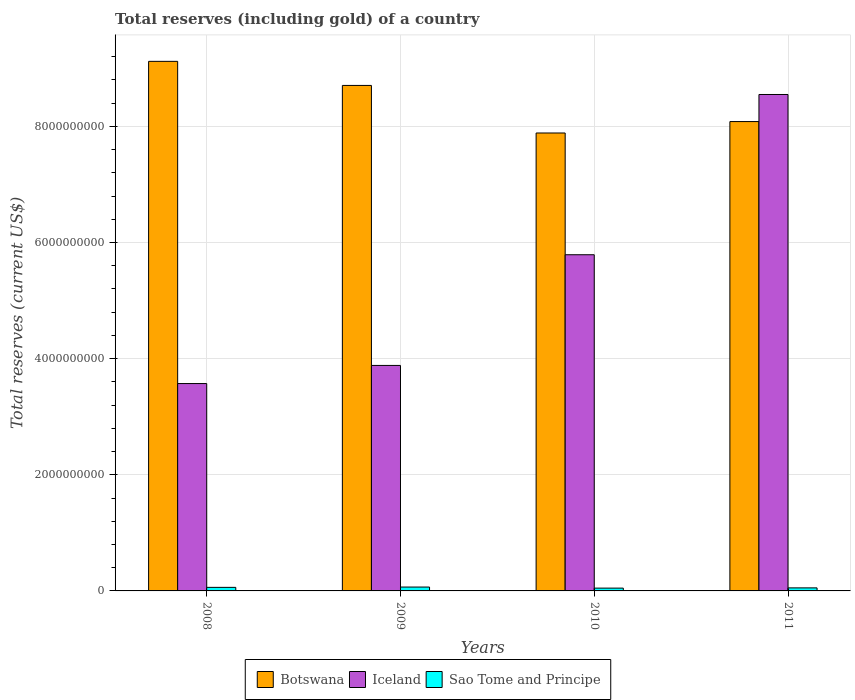How many groups of bars are there?
Offer a very short reply. 4. Are the number of bars on each tick of the X-axis equal?
Your answer should be compact. Yes. What is the total reserves (including gold) in Iceland in 2010?
Provide a succinct answer. 5.79e+09. Across all years, what is the maximum total reserves (including gold) in Sao Tome and Principe?
Keep it short and to the point. 6.67e+07. Across all years, what is the minimum total reserves (including gold) in Iceland?
Your response must be concise. 3.57e+09. What is the total total reserves (including gold) in Botswana in the graph?
Your answer should be compact. 3.38e+1. What is the difference between the total reserves (including gold) in Botswana in 2008 and that in 2009?
Provide a succinct answer. 4.15e+08. What is the difference between the total reserves (including gold) in Sao Tome and Principe in 2008 and the total reserves (including gold) in Iceland in 2010?
Keep it short and to the point. -5.73e+09. What is the average total reserves (including gold) in Botswana per year?
Your answer should be compact. 8.45e+09. In the year 2011, what is the difference between the total reserves (including gold) in Iceland and total reserves (including gold) in Botswana?
Ensure brevity in your answer.  4.66e+08. What is the ratio of the total reserves (including gold) in Sao Tome and Principe in 2009 to that in 2010?
Your answer should be very brief. 1.38. What is the difference between the highest and the second highest total reserves (including gold) in Sao Tome and Principe?
Provide a short and direct response. 5.37e+06. What is the difference between the highest and the lowest total reserves (including gold) in Sao Tome and Principe?
Your answer should be very brief. 1.85e+07. In how many years, is the total reserves (including gold) in Sao Tome and Principe greater than the average total reserves (including gold) in Sao Tome and Principe taken over all years?
Your answer should be compact. 2. What does the 1st bar from the left in 2011 represents?
Make the answer very short. Botswana. What does the 1st bar from the right in 2009 represents?
Offer a very short reply. Sao Tome and Principe. Is it the case that in every year, the sum of the total reserves (including gold) in Sao Tome and Principe and total reserves (including gold) in Botswana is greater than the total reserves (including gold) in Iceland?
Offer a very short reply. No. How many bars are there?
Your answer should be very brief. 12. Are the values on the major ticks of Y-axis written in scientific E-notation?
Offer a very short reply. No. Where does the legend appear in the graph?
Keep it short and to the point. Bottom center. What is the title of the graph?
Make the answer very short. Total reserves (including gold) of a country. What is the label or title of the Y-axis?
Provide a short and direct response. Total reserves (current US$). What is the Total reserves (current US$) in Botswana in 2008?
Make the answer very short. 9.12e+09. What is the Total reserves (current US$) of Iceland in 2008?
Give a very brief answer. 3.57e+09. What is the Total reserves (current US$) of Sao Tome and Principe in 2008?
Keep it short and to the point. 6.13e+07. What is the Total reserves (current US$) of Botswana in 2009?
Your answer should be compact. 8.70e+09. What is the Total reserves (current US$) in Iceland in 2009?
Ensure brevity in your answer.  3.88e+09. What is the Total reserves (current US$) in Sao Tome and Principe in 2009?
Keep it short and to the point. 6.67e+07. What is the Total reserves (current US$) in Botswana in 2010?
Offer a very short reply. 7.89e+09. What is the Total reserves (current US$) of Iceland in 2010?
Your answer should be very brief. 5.79e+09. What is the Total reserves (current US$) of Sao Tome and Principe in 2010?
Offer a terse response. 4.82e+07. What is the Total reserves (current US$) of Botswana in 2011?
Provide a short and direct response. 8.08e+09. What is the Total reserves (current US$) in Iceland in 2011?
Your response must be concise. 8.55e+09. What is the Total reserves (current US$) of Sao Tome and Principe in 2011?
Your answer should be very brief. 5.23e+07. Across all years, what is the maximum Total reserves (current US$) of Botswana?
Offer a terse response. 9.12e+09. Across all years, what is the maximum Total reserves (current US$) in Iceland?
Provide a short and direct response. 8.55e+09. Across all years, what is the maximum Total reserves (current US$) in Sao Tome and Principe?
Provide a succinct answer. 6.67e+07. Across all years, what is the minimum Total reserves (current US$) in Botswana?
Provide a succinct answer. 7.89e+09. Across all years, what is the minimum Total reserves (current US$) of Iceland?
Offer a very short reply. 3.57e+09. Across all years, what is the minimum Total reserves (current US$) in Sao Tome and Principe?
Offer a very short reply. 4.82e+07. What is the total Total reserves (current US$) of Botswana in the graph?
Give a very brief answer. 3.38e+1. What is the total Total reserves (current US$) in Iceland in the graph?
Keep it short and to the point. 2.18e+1. What is the total Total reserves (current US$) of Sao Tome and Principe in the graph?
Offer a very short reply. 2.28e+08. What is the difference between the Total reserves (current US$) of Botswana in 2008 and that in 2009?
Your response must be concise. 4.15e+08. What is the difference between the Total reserves (current US$) of Iceland in 2008 and that in 2009?
Make the answer very short. -3.12e+08. What is the difference between the Total reserves (current US$) in Sao Tome and Principe in 2008 and that in 2009?
Keep it short and to the point. -5.37e+06. What is the difference between the Total reserves (current US$) of Botswana in 2008 and that in 2010?
Give a very brief answer. 1.23e+09. What is the difference between the Total reserves (current US$) in Iceland in 2008 and that in 2010?
Your response must be concise. -2.22e+09. What is the difference between the Total reserves (current US$) of Sao Tome and Principe in 2008 and that in 2010?
Provide a succinct answer. 1.31e+07. What is the difference between the Total reserves (current US$) of Botswana in 2008 and that in 2011?
Your answer should be very brief. 1.04e+09. What is the difference between the Total reserves (current US$) of Iceland in 2008 and that in 2011?
Provide a short and direct response. -4.98e+09. What is the difference between the Total reserves (current US$) in Sao Tome and Principe in 2008 and that in 2011?
Offer a terse response. 8.99e+06. What is the difference between the Total reserves (current US$) of Botswana in 2009 and that in 2010?
Make the answer very short. 8.19e+08. What is the difference between the Total reserves (current US$) in Iceland in 2009 and that in 2010?
Your answer should be very brief. -1.91e+09. What is the difference between the Total reserves (current US$) of Sao Tome and Principe in 2009 and that in 2010?
Your answer should be compact. 1.85e+07. What is the difference between the Total reserves (current US$) in Botswana in 2009 and that in 2011?
Give a very brief answer. 6.22e+08. What is the difference between the Total reserves (current US$) in Iceland in 2009 and that in 2011?
Keep it short and to the point. -4.67e+09. What is the difference between the Total reserves (current US$) in Sao Tome and Principe in 2009 and that in 2011?
Make the answer very short. 1.44e+07. What is the difference between the Total reserves (current US$) in Botswana in 2010 and that in 2011?
Provide a short and direct response. -1.97e+08. What is the difference between the Total reserves (current US$) in Iceland in 2010 and that in 2011?
Provide a succinct answer. -2.76e+09. What is the difference between the Total reserves (current US$) of Sao Tome and Principe in 2010 and that in 2011?
Make the answer very short. -4.13e+06. What is the difference between the Total reserves (current US$) in Botswana in 2008 and the Total reserves (current US$) in Iceland in 2009?
Your answer should be compact. 5.24e+09. What is the difference between the Total reserves (current US$) of Botswana in 2008 and the Total reserves (current US$) of Sao Tome and Principe in 2009?
Your response must be concise. 9.05e+09. What is the difference between the Total reserves (current US$) in Iceland in 2008 and the Total reserves (current US$) in Sao Tome and Principe in 2009?
Provide a succinct answer. 3.50e+09. What is the difference between the Total reserves (current US$) of Botswana in 2008 and the Total reserves (current US$) of Iceland in 2010?
Offer a terse response. 3.33e+09. What is the difference between the Total reserves (current US$) in Botswana in 2008 and the Total reserves (current US$) in Sao Tome and Principe in 2010?
Offer a very short reply. 9.07e+09. What is the difference between the Total reserves (current US$) in Iceland in 2008 and the Total reserves (current US$) in Sao Tome and Principe in 2010?
Your answer should be very brief. 3.52e+09. What is the difference between the Total reserves (current US$) in Botswana in 2008 and the Total reserves (current US$) in Iceland in 2011?
Offer a terse response. 5.71e+08. What is the difference between the Total reserves (current US$) of Botswana in 2008 and the Total reserves (current US$) of Sao Tome and Principe in 2011?
Offer a terse response. 9.07e+09. What is the difference between the Total reserves (current US$) in Iceland in 2008 and the Total reserves (current US$) in Sao Tome and Principe in 2011?
Your answer should be compact. 3.52e+09. What is the difference between the Total reserves (current US$) in Botswana in 2009 and the Total reserves (current US$) in Iceland in 2010?
Your response must be concise. 2.92e+09. What is the difference between the Total reserves (current US$) of Botswana in 2009 and the Total reserves (current US$) of Sao Tome and Principe in 2010?
Ensure brevity in your answer.  8.66e+09. What is the difference between the Total reserves (current US$) of Iceland in 2009 and the Total reserves (current US$) of Sao Tome and Principe in 2010?
Ensure brevity in your answer.  3.83e+09. What is the difference between the Total reserves (current US$) in Botswana in 2009 and the Total reserves (current US$) in Iceland in 2011?
Your answer should be very brief. 1.56e+08. What is the difference between the Total reserves (current US$) in Botswana in 2009 and the Total reserves (current US$) in Sao Tome and Principe in 2011?
Provide a short and direct response. 8.65e+09. What is the difference between the Total reserves (current US$) of Iceland in 2009 and the Total reserves (current US$) of Sao Tome and Principe in 2011?
Give a very brief answer. 3.83e+09. What is the difference between the Total reserves (current US$) of Botswana in 2010 and the Total reserves (current US$) of Iceland in 2011?
Your answer should be very brief. -6.63e+08. What is the difference between the Total reserves (current US$) of Botswana in 2010 and the Total reserves (current US$) of Sao Tome and Principe in 2011?
Your response must be concise. 7.83e+09. What is the difference between the Total reserves (current US$) of Iceland in 2010 and the Total reserves (current US$) of Sao Tome and Principe in 2011?
Give a very brief answer. 5.74e+09. What is the average Total reserves (current US$) in Botswana per year?
Give a very brief answer. 8.45e+09. What is the average Total reserves (current US$) of Iceland per year?
Ensure brevity in your answer.  5.45e+09. What is the average Total reserves (current US$) of Sao Tome and Principe per year?
Your answer should be very brief. 5.71e+07. In the year 2008, what is the difference between the Total reserves (current US$) in Botswana and Total reserves (current US$) in Iceland?
Give a very brief answer. 5.55e+09. In the year 2008, what is the difference between the Total reserves (current US$) in Botswana and Total reserves (current US$) in Sao Tome and Principe?
Provide a short and direct response. 9.06e+09. In the year 2008, what is the difference between the Total reserves (current US$) of Iceland and Total reserves (current US$) of Sao Tome and Principe?
Make the answer very short. 3.51e+09. In the year 2009, what is the difference between the Total reserves (current US$) in Botswana and Total reserves (current US$) in Iceland?
Keep it short and to the point. 4.82e+09. In the year 2009, what is the difference between the Total reserves (current US$) of Botswana and Total reserves (current US$) of Sao Tome and Principe?
Offer a terse response. 8.64e+09. In the year 2009, what is the difference between the Total reserves (current US$) in Iceland and Total reserves (current US$) in Sao Tome and Principe?
Make the answer very short. 3.82e+09. In the year 2010, what is the difference between the Total reserves (current US$) in Botswana and Total reserves (current US$) in Iceland?
Your answer should be very brief. 2.10e+09. In the year 2010, what is the difference between the Total reserves (current US$) of Botswana and Total reserves (current US$) of Sao Tome and Principe?
Give a very brief answer. 7.84e+09. In the year 2010, what is the difference between the Total reserves (current US$) in Iceland and Total reserves (current US$) in Sao Tome and Principe?
Your response must be concise. 5.74e+09. In the year 2011, what is the difference between the Total reserves (current US$) in Botswana and Total reserves (current US$) in Iceland?
Provide a succinct answer. -4.66e+08. In the year 2011, what is the difference between the Total reserves (current US$) in Botswana and Total reserves (current US$) in Sao Tome and Principe?
Your response must be concise. 8.03e+09. In the year 2011, what is the difference between the Total reserves (current US$) in Iceland and Total reserves (current US$) in Sao Tome and Principe?
Give a very brief answer. 8.50e+09. What is the ratio of the Total reserves (current US$) of Botswana in 2008 to that in 2009?
Offer a very short reply. 1.05. What is the ratio of the Total reserves (current US$) of Iceland in 2008 to that in 2009?
Offer a terse response. 0.92. What is the ratio of the Total reserves (current US$) in Sao Tome and Principe in 2008 to that in 2009?
Offer a terse response. 0.92. What is the ratio of the Total reserves (current US$) in Botswana in 2008 to that in 2010?
Your answer should be compact. 1.16. What is the ratio of the Total reserves (current US$) in Iceland in 2008 to that in 2010?
Ensure brevity in your answer.  0.62. What is the ratio of the Total reserves (current US$) in Sao Tome and Principe in 2008 to that in 2010?
Provide a short and direct response. 1.27. What is the ratio of the Total reserves (current US$) in Botswana in 2008 to that in 2011?
Provide a short and direct response. 1.13. What is the ratio of the Total reserves (current US$) in Iceland in 2008 to that in 2011?
Your response must be concise. 0.42. What is the ratio of the Total reserves (current US$) in Sao Tome and Principe in 2008 to that in 2011?
Keep it short and to the point. 1.17. What is the ratio of the Total reserves (current US$) in Botswana in 2009 to that in 2010?
Make the answer very short. 1.1. What is the ratio of the Total reserves (current US$) in Iceland in 2009 to that in 2010?
Keep it short and to the point. 0.67. What is the ratio of the Total reserves (current US$) of Sao Tome and Principe in 2009 to that in 2010?
Ensure brevity in your answer.  1.38. What is the ratio of the Total reserves (current US$) in Botswana in 2009 to that in 2011?
Provide a succinct answer. 1.08. What is the ratio of the Total reserves (current US$) in Iceland in 2009 to that in 2011?
Provide a succinct answer. 0.45. What is the ratio of the Total reserves (current US$) in Sao Tome and Principe in 2009 to that in 2011?
Offer a very short reply. 1.27. What is the ratio of the Total reserves (current US$) of Botswana in 2010 to that in 2011?
Your answer should be compact. 0.98. What is the ratio of the Total reserves (current US$) in Iceland in 2010 to that in 2011?
Provide a short and direct response. 0.68. What is the ratio of the Total reserves (current US$) in Sao Tome and Principe in 2010 to that in 2011?
Offer a terse response. 0.92. What is the difference between the highest and the second highest Total reserves (current US$) of Botswana?
Offer a very short reply. 4.15e+08. What is the difference between the highest and the second highest Total reserves (current US$) in Iceland?
Give a very brief answer. 2.76e+09. What is the difference between the highest and the second highest Total reserves (current US$) of Sao Tome and Principe?
Keep it short and to the point. 5.37e+06. What is the difference between the highest and the lowest Total reserves (current US$) of Botswana?
Your response must be concise. 1.23e+09. What is the difference between the highest and the lowest Total reserves (current US$) of Iceland?
Offer a very short reply. 4.98e+09. What is the difference between the highest and the lowest Total reserves (current US$) in Sao Tome and Principe?
Your answer should be compact. 1.85e+07. 